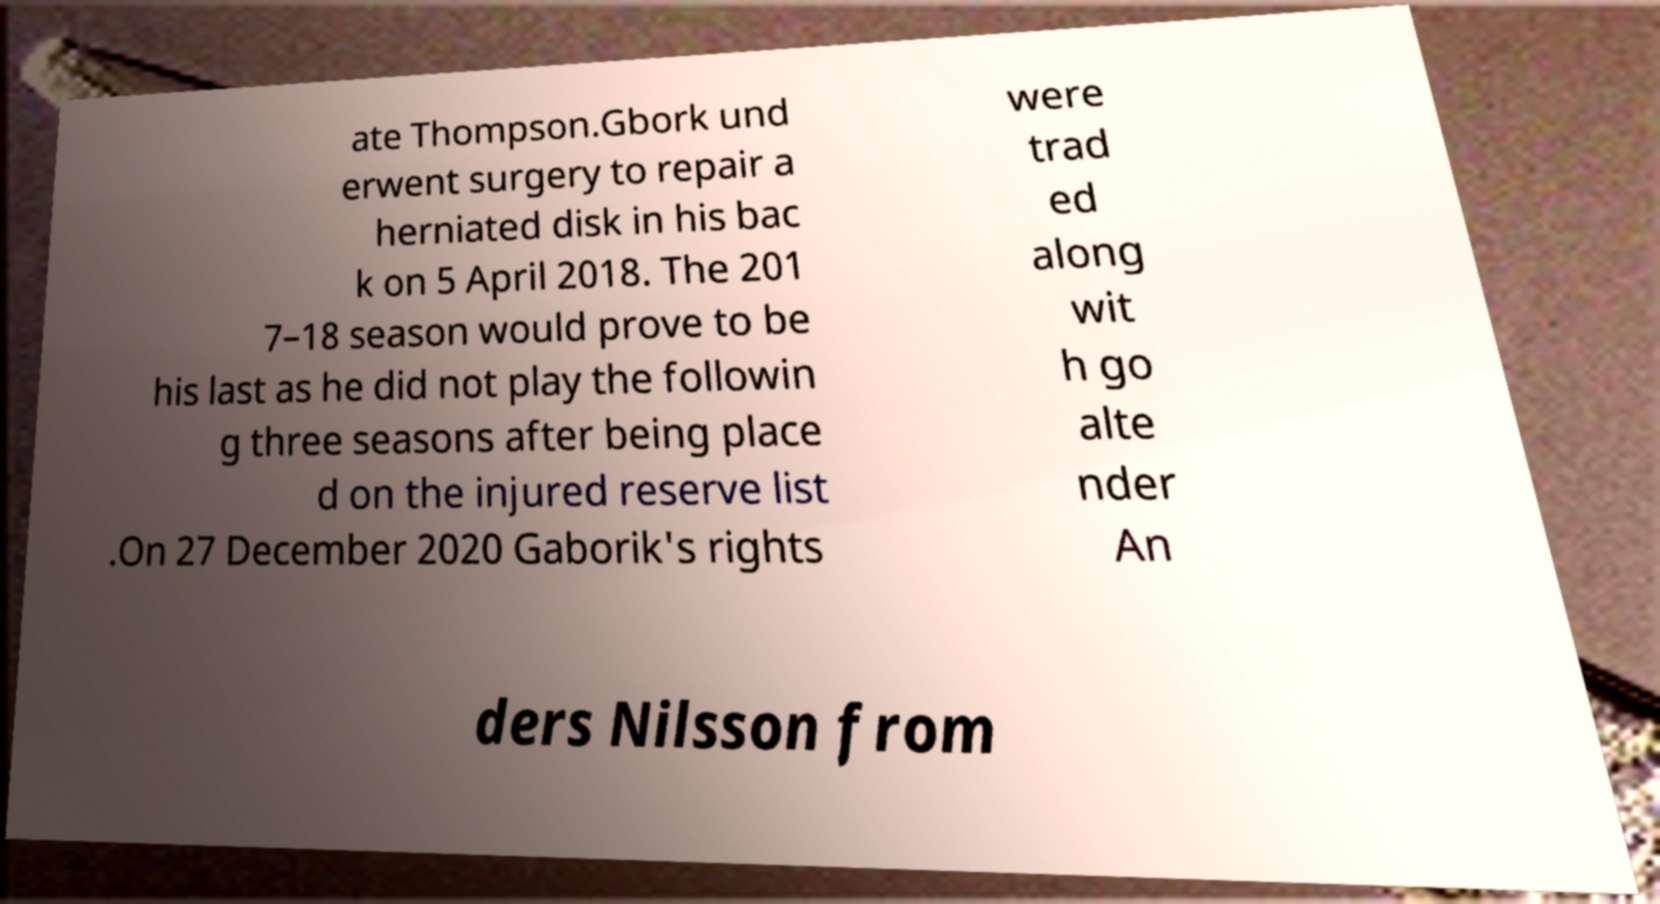Please read and relay the text visible in this image. What does it say? ate Thompson.Gbork und erwent surgery to repair a herniated disk in his bac k on 5 April 2018. The 201 7–18 season would prove to be his last as he did not play the followin g three seasons after being place d on the injured reserve list .On 27 December 2020 Gaborik's rights were trad ed along wit h go alte nder An ders Nilsson from 